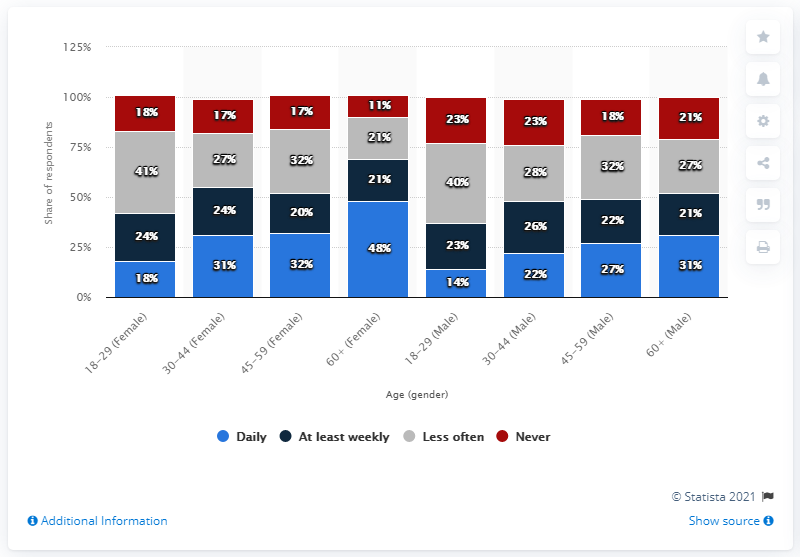Specify some key components in this picture. The light blue color indicates that the information pertains to daily updates. The total value of the grey bar is 248. 